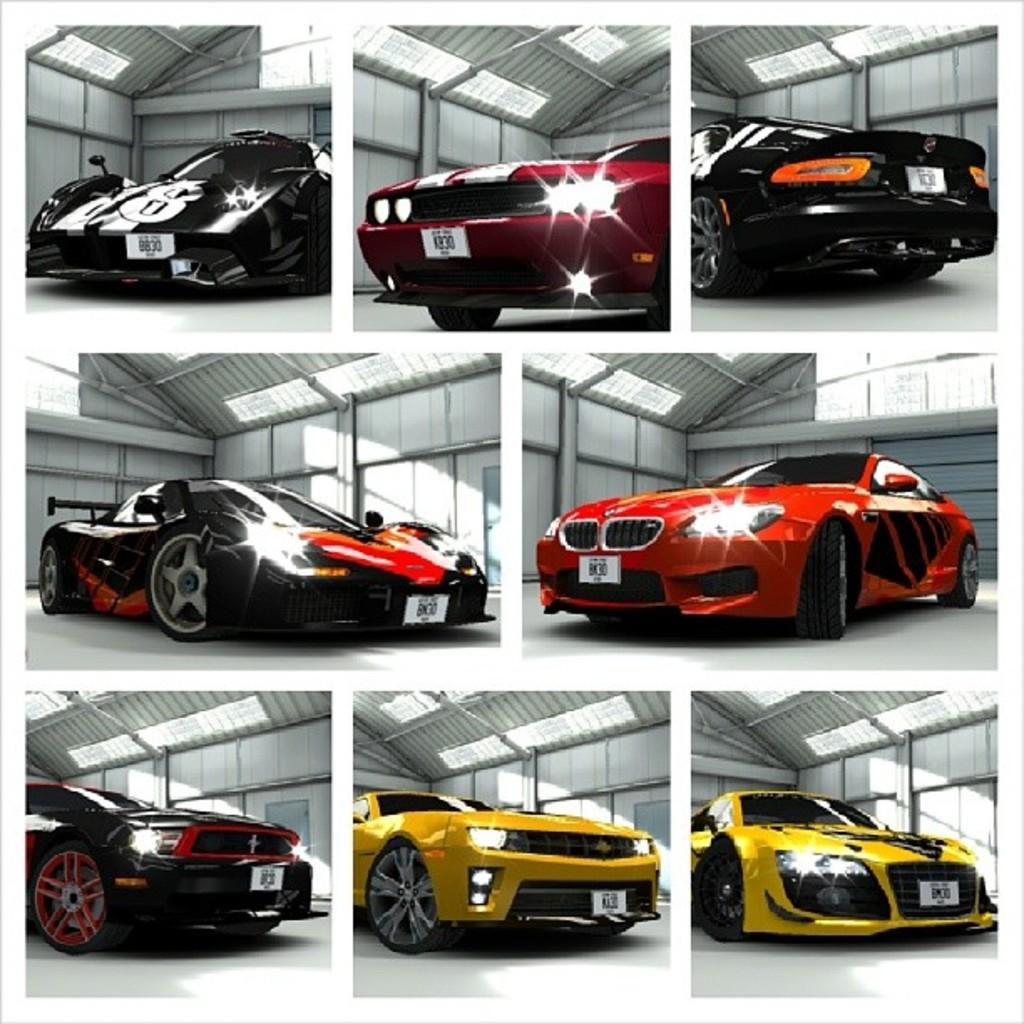What types of vehicles are present in the image? There are cars of different colors in the image. What else can be seen in the image besides the cars? There are lights in the image. Can you tell me how many people are carrying a sack in the image? There are no people or sacks present in the image; it only features cars and lights. 